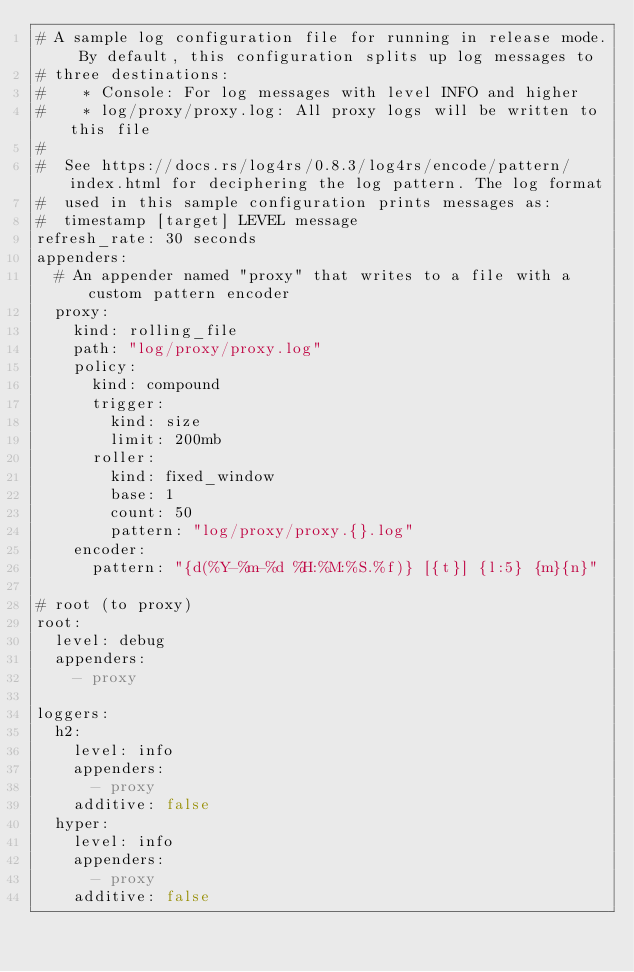<code> <loc_0><loc_0><loc_500><loc_500><_YAML_># A sample log configuration file for running in release mode. By default, this configuration splits up log messages to
# three destinations:
#    * Console: For log messages with level INFO and higher
#    * log/proxy/proxy.log: All proxy logs will be written to this file
#
#  See https://docs.rs/log4rs/0.8.3/log4rs/encode/pattern/index.html for deciphering the log pattern. The log format
#  used in this sample configuration prints messages as:
#  timestamp [target] LEVEL message
refresh_rate: 30 seconds
appenders:
  # An appender named "proxy" that writes to a file with a custom pattern encoder
  proxy:
    kind: rolling_file
    path: "log/proxy/proxy.log"
    policy:
      kind: compound
      trigger:
        kind: size
        limit: 200mb
      roller:
        kind: fixed_window
        base: 1
        count: 50
        pattern: "log/proxy/proxy.{}.log"
    encoder:
      pattern: "{d(%Y-%m-%d %H:%M:%S.%f)} [{t}] {l:5} {m}{n}"

# root (to proxy)
root:
  level: debug
  appenders:
    - proxy

loggers:
  h2:
    level: info
    appenders:
      - proxy
    additive: false
  hyper:
    level: info
    appenders:
      - proxy
    additive: false
  </code> 